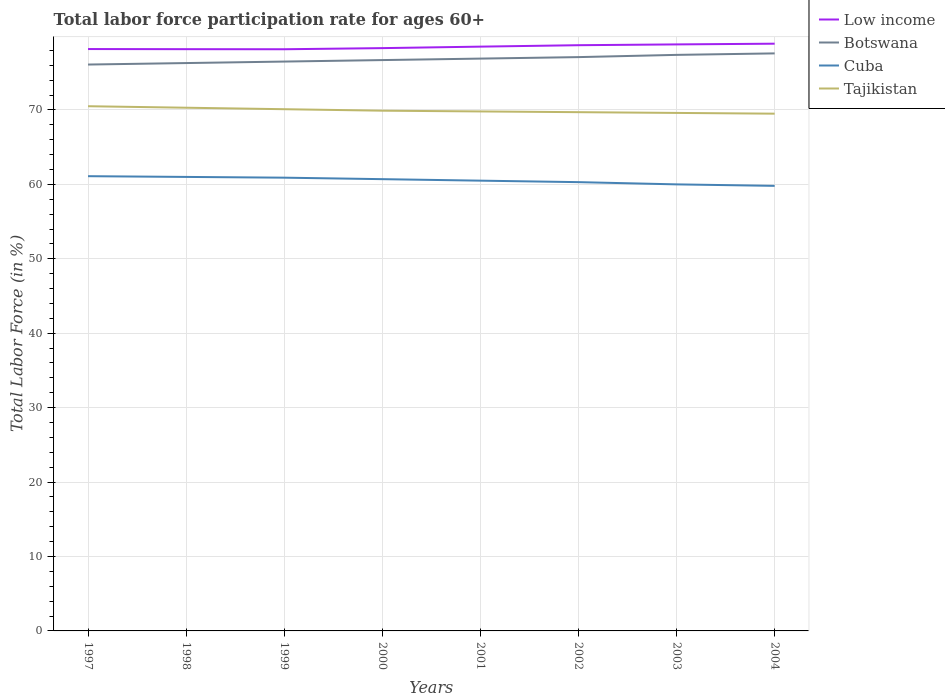Is the number of lines equal to the number of legend labels?
Keep it short and to the point. Yes. Across all years, what is the maximum labor force participation rate in Tajikistan?
Provide a short and direct response. 69.5. What is the total labor force participation rate in Low income in the graph?
Offer a very short reply. 0.02. What is the difference between the highest and the lowest labor force participation rate in Tajikistan?
Give a very brief answer. 3. How many lines are there?
Your answer should be very brief. 4. How many years are there in the graph?
Make the answer very short. 8. Are the values on the major ticks of Y-axis written in scientific E-notation?
Your response must be concise. No. Does the graph contain grids?
Keep it short and to the point. Yes. Where does the legend appear in the graph?
Your answer should be compact. Top right. How many legend labels are there?
Your answer should be very brief. 4. What is the title of the graph?
Your answer should be compact. Total labor force participation rate for ages 60+. What is the label or title of the X-axis?
Your answer should be compact. Years. What is the label or title of the Y-axis?
Offer a very short reply. Total Labor Force (in %). What is the Total Labor Force (in %) of Low income in 1997?
Offer a very short reply. 78.18. What is the Total Labor Force (in %) of Botswana in 1997?
Offer a very short reply. 76.1. What is the Total Labor Force (in %) in Cuba in 1997?
Offer a terse response. 61.1. What is the Total Labor Force (in %) of Tajikistan in 1997?
Provide a succinct answer. 70.5. What is the Total Labor Force (in %) in Low income in 1998?
Offer a terse response. 78.16. What is the Total Labor Force (in %) in Botswana in 1998?
Provide a short and direct response. 76.3. What is the Total Labor Force (in %) in Cuba in 1998?
Ensure brevity in your answer.  61. What is the Total Labor Force (in %) in Tajikistan in 1998?
Make the answer very short. 70.3. What is the Total Labor Force (in %) of Low income in 1999?
Offer a terse response. 78.16. What is the Total Labor Force (in %) of Botswana in 1999?
Provide a succinct answer. 76.5. What is the Total Labor Force (in %) of Cuba in 1999?
Ensure brevity in your answer.  60.9. What is the Total Labor Force (in %) in Tajikistan in 1999?
Your answer should be compact. 70.1. What is the Total Labor Force (in %) in Low income in 2000?
Provide a short and direct response. 78.31. What is the Total Labor Force (in %) of Botswana in 2000?
Provide a succinct answer. 76.7. What is the Total Labor Force (in %) of Cuba in 2000?
Your response must be concise. 60.7. What is the Total Labor Force (in %) in Tajikistan in 2000?
Make the answer very short. 69.9. What is the Total Labor Force (in %) of Low income in 2001?
Give a very brief answer. 78.51. What is the Total Labor Force (in %) of Botswana in 2001?
Provide a short and direct response. 76.9. What is the Total Labor Force (in %) of Cuba in 2001?
Keep it short and to the point. 60.5. What is the Total Labor Force (in %) of Tajikistan in 2001?
Make the answer very short. 69.8. What is the Total Labor Force (in %) of Low income in 2002?
Make the answer very short. 78.7. What is the Total Labor Force (in %) in Botswana in 2002?
Your answer should be compact. 77.1. What is the Total Labor Force (in %) of Cuba in 2002?
Provide a short and direct response. 60.3. What is the Total Labor Force (in %) of Tajikistan in 2002?
Provide a short and direct response. 69.7. What is the Total Labor Force (in %) of Low income in 2003?
Your response must be concise. 78.81. What is the Total Labor Force (in %) of Botswana in 2003?
Your answer should be compact. 77.4. What is the Total Labor Force (in %) in Tajikistan in 2003?
Keep it short and to the point. 69.6. What is the Total Labor Force (in %) in Low income in 2004?
Provide a short and direct response. 78.9. What is the Total Labor Force (in %) of Botswana in 2004?
Your response must be concise. 77.6. What is the Total Labor Force (in %) of Cuba in 2004?
Provide a short and direct response. 59.8. What is the Total Labor Force (in %) in Tajikistan in 2004?
Offer a terse response. 69.5. Across all years, what is the maximum Total Labor Force (in %) of Low income?
Make the answer very short. 78.9. Across all years, what is the maximum Total Labor Force (in %) in Botswana?
Your answer should be very brief. 77.6. Across all years, what is the maximum Total Labor Force (in %) of Cuba?
Your answer should be compact. 61.1. Across all years, what is the maximum Total Labor Force (in %) of Tajikistan?
Give a very brief answer. 70.5. Across all years, what is the minimum Total Labor Force (in %) of Low income?
Your answer should be very brief. 78.16. Across all years, what is the minimum Total Labor Force (in %) in Botswana?
Give a very brief answer. 76.1. Across all years, what is the minimum Total Labor Force (in %) of Cuba?
Keep it short and to the point. 59.8. Across all years, what is the minimum Total Labor Force (in %) of Tajikistan?
Your response must be concise. 69.5. What is the total Total Labor Force (in %) of Low income in the graph?
Keep it short and to the point. 627.72. What is the total Total Labor Force (in %) of Botswana in the graph?
Offer a terse response. 614.6. What is the total Total Labor Force (in %) in Cuba in the graph?
Ensure brevity in your answer.  484.3. What is the total Total Labor Force (in %) of Tajikistan in the graph?
Provide a short and direct response. 559.4. What is the difference between the Total Labor Force (in %) in Low income in 1997 and that in 1998?
Keep it short and to the point. 0.02. What is the difference between the Total Labor Force (in %) in Cuba in 1997 and that in 1998?
Your answer should be compact. 0.1. What is the difference between the Total Labor Force (in %) in Low income in 1997 and that in 1999?
Give a very brief answer. 0.03. What is the difference between the Total Labor Force (in %) in Botswana in 1997 and that in 1999?
Your response must be concise. -0.4. What is the difference between the Total Labor Force (in %) in Cuba in 1997 and that in 1999?
Keep it short and to the point. 0.2. What is the difference between the Total Labor Force (in %) in Low income in 1997 and that in 2000?
Keep it short and to the point. -0.12. What is the difference between the Total Labor Force (in %) of Botswana in 1997 and that in 2000?
Keep it short and to the point. -0.6. What is the difference between the Total Labor Force (in %) of Cuba in 1997 and that in 2000?
Give a very brief answer. 0.4. What is the difference between the Total Labor Force (in %) of Low income in 1997 and that in 2001?
Provide a succinct answer. -0.33. What is the difference between the Total Labor Force (in %) in Botswana in 1997 and that in 2001?
Your answer should be compact. -0.8. What is the difference between the Total Labor Force (in %) in Cuba in 1997 and that in 2001?
Your response must be concise. 0.6. What is the difference between the Total Labor Force (in %) of Low income in 1997 and that in 2002?
Ensure brevity in your answer.  -0.52. What is the difference between the Total Labor Force (in %) of Cuba in 1997 and that in 2002?
Provide a succinct answer. 0.8. What is the difference between the Total Labor Force (in %) in Low income in 1997 and that in 2003?
Give a very brief answer. -0.62. What is the difference between the Total Labor Force (in %) in Cuba in 1997 and that in 2003?
Give a very brief answer. 1.1. What is the difference between the Total Labor Force (in %) in Tajikistan in 1997 and that in 2003?
Provide a succinct answer. 0.9. What is the difference between the Total Labor Force (in %) in Low income in 1997 and that in 2004?
Give a very brief answer. -0.72. What is the difference between the Total Labor Force (in %) of Botswana in 1997 and that in 2004?
Your answer should be compact. -1.5. What is the difference between the Total Labor Force (in %) of Cuba in 1997 and that in 2004?
Make the answer very short. 1.3. What is the difference between the Total Labor Force (in %) in Low income in 1998 and that in 1999?
Ensure brevity in your answer.  0.01. What is the difference between the Total Labor Force (in %) in Botswana in 1998 and that in 1999?
Provide a short and direct response. -0.2. What is the difference between the Total Labor Force (in %) in Low income in 1998 and that in 2000?
Ensure brevity in your answer.  -0.14. What is the difference between the Total Labor Force (in %) of Botswana in 1998 and that in 2000?
Your answer should be compact. -0.4. What is the difference between the Total Labor Force (in %) in Tajikistan in 1998 and that in 2000?
Provide a succinct answer. 0.4. What is the difference between the Total Labor Force (in %) of Low income in 1998 and that in 2001?
Keep it short and to the point. -0.34. What is the difference between the Total Labor Force (in %) in Cuba in 1998 and that in 2001?
Your answer should be compact. 0.5. What is the difference between the Total Labor Force (in %) in Low income in 1998 and that in 2002?
Provide a succinct answer. -0.53. What is the difference between the Total Labor Force (in %) of Tajikistan in 1998 and that in 2002?
Make the answer very short. 0.6. What is the difference between the Total Labor Force (in %) of Low income in 1998 and that in 2003?
Your response must be concise. -0.64. What is the difference between the Total Labor Force (in %) of Botswana in 1998 and that in 2003?
Offer a terse response. -1.1. What is the difference between the Total Labor Force (in %) in Low income in 1998 and that in 2004?
Offer a very short reply. -0.74. What is the difference between the Total Labor Force (in %) in Botswana in 1998 and that in 2004?
Provide a short and direct response. -1.3. What is the difference between the Total Labor Force (in %) of Tajikistan in 1998 and that in 2004?
Offer a terse response. 0.8. What is the difference between the Total Labor Force (in %) in Low income in 1999 and that in 2000?
Provide a succinct answer. -0.15. What is the difference between the Total Labor Force (in %) of Cuba in 1999 and that in 2000?
Offer a terse response. 0.2. What is the difference between the Total Labor Force (in %) in Tajikistan in 1999 and that in 2000?
Keep it short and to the point. 0.2. What is the difference between the Total Labor Force (in %) in Low income in 1999 and that in 2001?
Your answer should be compact. -0.35. What is the difference between the Total Labor Force (in %) in Low income in 1999 and that in 2002?
Your response must be concise. -0.54. What is the difference between the Total Labor Force (in %) in Botswana in 1999 and that in 2002?
Your answer should be compact. -0.6. What is the difference between the Total Labor Force (in %) in Cuba in 1999 and that in 2002?
Keep it short and to the point. 0.6. What is the difference between the Total Labor Force (in %) in Tajikistan in 1999 and that in 2002?
Your answer should be compact. 0.4. What is the difference between the Total Labor Force (in %) of Low income in 1999 and that in 2003?
Your response must be concise. -0.65. What is the difference between the Total Labor Force (in %) of Botswana in 1999 and that in 2003?
Give a very brief answer. -0.9. What is the difference between the Total Labor Force (in %) in Cuba in 1999 and that in 2003?
Your answer should be very brief. 0.9. What is the difference between the Total Labor Force (in %) of Tajikistan in 1999 and that in 2003?
Offer a terse response. 0.5. What is the difference between the Total Labor Force (in %) in Low income in 1999 and that in 2004?
Provide a short and direct response. -0.75. What is the difference between the Total Labor Force (in %) in Botswana in 1999 and that in 2004?
Your answer should be compact. -1.1. What is the difference between the Total Labor Force (in %) of Low income in 2000 and that in 2001?
Provide a short and direct response. -0.2. What is the difference between the Total Labor Force (in %) of Botswana in 2000 and that in 2001?
Your response must be concise. -0.2. What is the difference between the Total Labor Force (in %) of Low income in 2000 and that in 2002?
Your answer should be very brief. -0.39. What is the difference between the Total Labor Force (in %) in Low income in 2000 and that in 2003?
Offer a very short reply. -0.5. What is the difference between the Total Labor Force (in %) in Botswana in 2000 and that in 2003?
Your answer should be compact. -0.7. What is the difference between the Total Labor Force (in %) of Cuba in 2000 and that in 2003?
Your response must be concise. 0.7. What is the difference between the Total Labor Force (in %) of Low income in 2000 and that in 2004?
Provide a short and direct response. -0.6. What is the difference between the Total Labor Force (in %) of Botswana in 2000 and that in 2004?
Your response must be concise. -0.9. What is the difference between the Total Labor Force (in %) of Cuba in 2000 and that in 2004?
Keep it short and to the point. 0.9. What is the difference between the Total Labor Force (in %) of Tajikistan in 2000 and that in 2004?
Keep it short and to the point. 0.4. What is the difference between the Total Labor Force (in %) of Low income in 2001 and that in 2002?
Your answer should be very brief. -0.19. What is the difference between the Total Labor Force (in %) in Botswana in 2001 and that in 2002?
Offer a terse response. -0.2. What is the difference between the Total Labor Force (in %) of Low income in 2001 and that in 2003?
Give a very brief answer. -0.3. What is the difference between the Total Labor Force (in %) in Cuba in 2001 and that in 2003?
Provide a succinct answer. 0.5. What is the difference between the Total Labor Force (in %) in Low income in 2001 and that in 2004?
Offer a terse response. -0.4. What is the difference between the Total Labor Force (in %) of Low income in 2002 and that in 2003?
Give a very brief answer. -0.11. What is the difference between the Total Labor Force (in %) of Botswana in 2002 and that in 2003?
Keep it short and to the point. -0.3. What is the difference between the Total Labor Force (in %) of Tajikistan in 2002 and that in 2003?
Make the answer very short. 0.1. What is the difference between the Total Labor Force (in %) in Low income in 2002 and that in 2004?
Offer a terse response. -0.2. What is the difference between the Total Labor Force (in %) in Low income in 2003 and that in 2004?
Give a very brief answer. -0.1. What is the difference between the Total Labor Force (in %) in Tajikistan in 2003 and that in 2004?
Offer a very short reply. 0.1. What is the difference between the Total Labor Force (in %) of Low income in 1997 and the Total Labor Force (in %) of Botswana in 1998?
Provide a short and direct response. 1.88. What is the difference between the Total Labor Force (in %) in Low income in 1997 and the Total Labor Force (in %) in Cuba in 1998?
Provide a short and direct response. 17.18. What is the difference between the Total Labor Force (in %) of Low income in 1997 and the Total Labor Force (in %) of Tajikistan in 1998?
Your answer should be very brief. 7.88. What is the difference between the Total Labor Force (in %) of Botswana in 1997 and the Total Labor Force (in %) of Cuba in 1998?
Your answer should be compact. 15.1. What is the difference between the Total Labor Force (in %) of Cuba in 1997 and the Total Labor Force (in %) of Tajikistan in 1998?
Make the answer very short. -9.2. What is the difference between the Total Labor Force (in %) of Low income in 1997 and the Total Labor Force (in %) of Botswana in 1999?
Make the answer very short. 1.68. What is the difference between the Total Labor Force (in %) in Low income in 1997 and the Total Labor Force (in %) in Cuba in 1999?
Provide a short and direct response. 17.28. What is the difference between the Total Labor Force (in %) of Low income in 1997 and the Total Labor Force (in %) of Tajikistan in 1999?
Your response must be concise. 8.08. What is the difference between the Total Labor Force (in %) of Botswana in 1997 and the Total Labor Force (in %) of Tajikistan in 1999?
Provide a succinct answer. 6. What is the difference between the Total Labor Force (in %) in Cuba in 1997 and the Total Labor Force (in %) in Tajikistan in 1999?
Offer a very short reply. -9. What is the difference between the Total Labor Force (in %) of Low income in 1997 and the Total Labor Force (in %) of Botswana in 2000?
Offer a very short reply. 1.48. What is the difference between the Total Labor Force (in %) in Low income in 1997 and the Total Labor Force (in %) in Cuba in 2000?
Ensure brevity in your answer.  17.48. What is the difference between the Total Labor Force (in %) in Low income in 1997 and the Total Labor Force (in %) in Tajikistan in 2000?
Your answer should be compact. 8.28. What is the difference between the Total Labor Force (in %) of Cuba in 1997 and the Total Labor Force (in %) of Tajikistan in 2000?
Make the answer very short. -8.8. What is the difference between the Total Labor Force (in %) in Low income in 1997 and the Total Labor Force (in %) in Botswana in 2001?
Make the answer very short. 1.28. What is the difference between the Total Labor Force (in %) in Low income in 1997 and the Total Labor Force (in %) in Cuba in 2001?
Your response must be concise. 17.68. What is the difference between the Total Labor Force (in %) in Low income in 1997 and the Total Labor Force (in %) in Tajikistan in 2001?
Keep it short and to the point. 8.38. What is the difference between the Total Labor Force (in %) of Botswana in 1997 and the Total Labor Force (in %) of Tajikistan in 2001?
Offer a terse response. 6.3. What is the difference between the Total Labor Force (in %) in Cuba in 1997 and the Total Labor Force (in %) in Tajikistan in 2001?
Your answer should be compact. -8.7. What is the difference between the Total Labor Force (in %) of Low income in 1997 and the Total Labor Force (in %) of Botswana in 2002?
Ensure brevity in your answer.  1.08. What is the difference between the Total Labor Force (in %) in Low income in 1997 and the Total Labor Force (in %) in Cuba in 2002?
Your answer should be compact. 17.88. What is the difference between the Total Labor Force (in %) of Low income in 1997 and the Total Labor Force (in %) of Tajikistan in 2002?
Provide a succinct answer. 8.48. What is the difference between the Total Labor Force (in %) in Botswana in 1997 and the Total Labor Force (in %) in Cuba in 2002?
Offer a terse response. 15.8. What is the difference between the Total Labor Force (in %) in Botswana in 1997 and the Total Labor Force (in %) in Tajikistan in 2002?
Give a very brief answer. 6.4. What is the difference between the Total Labor Force (in %) in Cuba in 1997 and the Total Labor Force (in %) in Tajikistan in 2002?
Make the answer very short. -8.6. What is the difference between the Total Labor Force (in %) of Low income in 1997 and the Total Labor Force (in %) of Botswana in 2003?
Provide a short and direct response. 0.78. What is the difference between the Total Labor Force (in %) of Low income in 1997 and the Total Labor Force (in %) of Cuba in 2003?
Offer a very short reply. 18.18. What is the difference between the Total Labor Force (in %) of Low income in 1997 and the Total Labor Force (in %) of Tajikistan in 2003?
Keep it short and to the point. 8.58. What is the difference between the Total Labor Force (in %) in Botswana in 1997 and the Total Labor Force (in %) in Cuba in 2003?
Provide a short and direct response. 16.1. What is the difference between the Total Labor Force (in %) of Botswana in 1997 and the Total Labor Force (in %) of Tajikistan in 2003?
Keep it short and to the point. 6.5. What is the difference between the Total Labor Force (in %) of Low income in 1997 and the Total Labor Force (in %) of Botswana in 2004?
Give a very brief answer. 0.58. What is the difference between the Total Labor Force (in %) in Low income in 1997 and the Total Labor Force (in %) in Cuba in 2004?
Your response must be concise. 18.38. What is the difference between the Total Labor Force (in %) of Low income in 1997 and the Total Labor Force (in %) of Tajikistan in 2004?
Your answer should be very brief. 8.68. What is the difference between the Total Labor Force (in %) of Botswana in 1997 and the Total Labor Force (in %) of Cuba in 2004?
Offer a terse response. 16.3. What is the difference between the Total Labor Force (in %) of Botswana in 1997 and the Total Labor Force (in %) of Tajikistan in 2004?
Provide a short and direct response. 6.6. What is the difference between the Total Labor Force (in %) of Cuba in 1997 and the Total Labor Force (in %) of Tajikistan in 2004?
Your answer should be compact. -8.4. What is the difference between the Total Labor Force (in %) in Low income in 1998 and the Total Labor Force (in %) in Botswana in 1999?
Offer a very short reply. 1.66. What is the difference between the Total Labor Force (in %) of Low income in 1998 and the Total Labor Force (in %) of Cuba in 1999?
Provide a succinct answer. 17.26. What is the difference between the Total Labor Force (in %) of Low income in 1998 and the Total Labor Force (in %) of Tajikistan in 1999?
Your answer should be very brief. 8.06. What is the difference between the Total Labor Force (in %) in Cuba in 1998 and the Total Labor Force (in %) in Tajikistan in 1999?
Give a very brief answer. -9.1. What is the difference between the Total Labor Force (in %) in Low income in 1998 and the Total Labor Force (in %) in Botswana in 2000?
Offer a very short reply. 1.46. What is the difference between the Total Labor Force (in %) of Low income in 1998 and the Total Labor Force (in %) of Cuba in 2000?
Offer a terse response. 17.46. What is the difference between the Total Labor Force (in %) in Low income in 1998 and the Total Labor Force (in %) in Tajikistan in 2000?
Give a very brief answer. 8.26. What is the difference between the Total Labor Force (in %) of Botswana in 1998 and the Total Labor Force (in %) of Cuba in 2000?
Keep it short and to the point. 15.6. What is the difference between the Total Labor Force (in %) of Low income in 1998 and the Total Labor Force (in %) of Botswana in 2001?
Your answer should be very brief. 1.26. What is the difference between the Total Labor Force (in %) in Low income in 1998 and the Total Labor Force (in %) in Cuba in 2001?
Your response must be concise. 17.66. What is the difference between the Total Labor Force (in %) in Low income in 1998 and the Total Labor Force (in %) in Tajikistan in 2001?
Provide a succinct answer. 8.36. What is the difference between the Total Labor Force (in %) of Low income in 1998 and the Total Labor Force (in %) of Botswana in 2002?
Provide a succinct answer. 1.06. What is the difference between the Total Labor Force (in %) of Low income in 1998 and the Total Labor Force (in %) of Cuba in 2002?
Make the answer very short. 17.86. What is the difference between the Total Labor Force (in %) in Low income in 1998 and the Total Labor Force (in %) in Tajikistan in 2002?
Ensure brevity in your answer.  8.46. What is the difference between the Total Labor Force (in %) of Low income in 1998 and the Total Labor Force (in %) of Botswana in 2003?
Your answer should be very brief. 0.76. What is the difference between the Total Labor Force (in %) of Low income in 1998 and the Total Labor Force (in %) of Cuba in 2003?
Give a very brief answer. 18.16. What is the difference between the Total Labor Force (in %) of Low income in 1998 and the Total Labor Force (in %) of Tajikistan in 2003?
Offer a very short reply. 8.56. What is the difference between the Total Labor Force (in %) in Botswana in 1998 and the Total Labor Force (in %) in Cuba in 2003?
Keep it short and to the point. 16.3. What is the difference between the Total Labor Force (in %) in Low income in 1998 and the Total Labor Force (in %) in Botswana in 2004?
Make the answer very short. 0.56. What is the difference between the Total Labor Force (in %) in Low income in 1998 and the Total Labor Force (in %) in Cuba in 2004?
Offer a terse response. 18.36. What is the difference between the Total Labor Force (in %) in Low income in 1998 and the Total Labor Force (in %) in Tajikistan in 2004?
Offer a very short reply. 8.66. What is the difference between the Total Labor Force (in %) of Cuba in 1998 and the Total Labor Force (in %) of Tajikistan in 2004?
Offer a terse response. -8.5. What is the difference between the Total Labor Force (in %) of Low income in 1999 and the Total Labor Force (in %) of Botswana in 2000?
Your answer should be compact. 1.46. What is the difference between the Total Labor Force (in %) in Low income in 1999 and the Total Labor Force (in %) in Cuba in 2000?
Your answer should be very brief. 17.46. What is the difference between the Total Labor Force (in %) of Low income in 1999 and the Total Labor Force (in %) of Tajikistan in 2000?
Your response must be concise. 8.26. What is the difference between the Total Labor Force (in %) in Botswana in 1999 and the Total Labor Force (in %) in Cuba in 2000?
Your response must be concise. 15.8. What is the difference between the Total Labor Force (in %) of Low income in 1999 and the Total Labor Force (in %) of Botswana in 2001?
Your answer should be very brief. 1.26. What is the difference between the Total Labor Force (in %) in Low income in 1999 and the Total Labor Force (in %) in Cuba in 2001?
Your response must be concise. 17.66. What is the difference between the Total Labor Force (in %) of Low income in 1999 and the Total Labor Force (in %) of Tajikistan in 2001?
Provide a short and direct response. 8.36. What is the difference between the Total Labor Force (in %) of Low income in 1999 and the Total Labor Force (in %) of Botswana in 2002?
Make the answer very short. 1.06. What is the difference between the Total Labor Force (in %) in Low income in 1999 and the Total Labor Force (in %) in Cuba in 2002?
Your answer should be compact. 17.86. What is the difference between the Total Labor Force (in %) of Low income in 1999 and the Total Labor Force (in %) of Tajikistan in 2002?
Your answer should be compact. 8.46. What is the difference between the Total Labor Force (in %) of Botswana in 1999 and the Total Labor Force (in %) of Cuba in 2002?
Your answer should be very brief. 16.2. What is the difference between the Total Labor Force (in %) of Cuba in 1999 and the Total Labor Force (in %) of Tajikistan in 2002?
Offer a very short reply. -8.8. What is the difference between the Total Labor Force (in %) in Low income in 1999 and the Total Labor Force (in %) in Botswana in 2003?
Your response must be concise. 0.76. What is the difference between the Total Labor Force (in %) of Low income in 1999 and the Total Labor Force (in %) of Cuba in 2003?
Your answer should be compact. 18.16. What is the difference between the Total Labor Force (in %) of Low income in 1999 and the Total Labor Force (in %) of Tajikistan in 2003?
Make the answer very short. 8.56. What is the difference between the Total Labor Force (in %) of Botswana in 1999 and the Total Labor Force (in %) of Tajikistan in 2003?
Offer a terse response. 6.9. What is the difference between the Total Labor Force (in %) of Low income in 1999 and the Total Labor Force (in %) of Botswana in 2004?
Ensure brevity in your answer.  0.56. What is the difference between the Total Labor Force (in %) of Low income in 1999 and the Total Labor Force (in %) of Cuba in 2004?
Provide a short and direct response. 18.36. What is the difference between the Total Labor Force (in %) of Low income in 1999 and the Total Labor Force (in %) of Tajikistan in 2004?
Ensure brevity in your answer.  8.66. What is the difference between the Total Labor Force (in %) of Low income in 2000 and the Total Labor Force (in %) of Botswana in 2001?
Your response must be concise. 1.41. What is the difference between the Total Labor Force (in %) of Low income in 2000 and the Total Labor Force (in %) of Cuba in 2001?
Make the answer very short. 17.81. What is the difference between the Total Labor Force (in %) in Low income in 2000 and the Total Labor Force (in %) in Tajikistan in 2001?
Ensure brevity in your answer.  8.51. What is the difference between the Total Labor Force (in %) of Botswana in 2000 and the Total Labor Force (in %) of Tajikistan in 2001?
Make the answer very short. 6.9. What is the difference between the Total Labor Force (in %) of Cuba in 2000 and the Total Labor Force (in %) of Tajikistan in 2001?
Provide a short and direct response. -9.1. What is the difference between the Total Labor Force (in %) in Low income in 2000 and the Total Labor Force (in %) in Botswana in 2002?
Offer a very short reply. 1.21. What is the difference between the Total Labor Force (in %) in Low income in 2000 and the Total Labor Force (in %) in Cuba in 2002?
Make the answer very short. 18.01. What is the difference between the Total Labor Force (in %) of Low income in 2000 and the Total Labor Force (in %) of Tajikistan in 2002?
Make the answer very short. 8.61. What is the difference between the Total Labor Force (in %) in Botswana in 2000 and the Total Labor Force (in %) in Tajikistan in 2002?
Your answer should be very brief. 7. What is the difference between the Total Labor Force (in %) in Cuba in 2000 and the Total Labor Force (in %) in Tajikistan in 2002?
Offer a terse response. -9. What is the difference between the Total Labor Force (in %) of Low income in 2000 and the Total Labor Force (in %) of Botswana in 2003?
Your answer should be compact. 0.91. What is the difference between the Total Labor Force (in %) in Low income in 2000 and the Total Labor Force (in %) in Cuba in 2003?
Offer a very short reply. 18.31. What is the difference between the Total Labor Force (in %) in Low income in 2000 and the Total Labor Force (in %) in Tajikistan in 2003?
Your answer should be compact. 8.71. What is the difference between the Total Labor Force (in %) of Botswana in 2000 and the Total Labor Force (in %) of Cuba in 2003?
Make the answer very short. 16.7. What is the difference between the Total Labor Force (in %) in Botswana in 2000 and the Total Labor Force (in %) in Tajikistan in 2003?
Provide a succinct answer. 7.1. What is the difference between the Total Labor Force (in %) of Low income in 2000 and the Total Labor Force (in %) of Botswana in 2004?
Offer a very short reply. 0.71. What is the difference between the Total Labor Force (in %) of Low income in 2000 and the Total Labor Force (in %) of Cuba in 2004?
Your answer should be compact. 18.51. What is the difference between the Total Labor Force (in %) of Low income in 2000 and the Total Labor Force (in %) of Tajikistan in 2004?
Ensure brevity in your answer.  8.81. What is the difference between the Total Labor Force (in %) of Botswana in 2000 and the Total Labor Force (in %) of Cuba in 2004?
Offer a terse response. 16.9. What is the difference between the Total Labor Force (in %) of Cuba in 2000 and the Total Labor Force (in %) of Tajikistan in 2004?
Your answer should be compact. -8.8. What is the difference between the Total Labor Force (in %) of Low income in 2001 and the Total Labor Force (in %) of Botswana in 2002?
Your response must be concise. 1.41. What is the difference between the Total Labor Force (in %) in Low income in 2001 and the Total Labor Force (in %) in Cuba in 2002?
Keep it short and to the point. 18.21. What is the difference between the Total Labor Force (in %) in Low income in 2001 and the Total Labor Force (in %) in Tajikistan in 2002?
Make the answer very short. 8.81. What is the difference between the Total Labor Force (in %) in Cuba in 2001 and the Total Labor Force (in %) in Tajikistan in 2002?
Keep it short and to the point. -9.2. What is the difference between the Total Labor Force (in %) in Low income in 2001 and the Total Labor Force (in %) in Botswana in 2003?
Offer a terse response. 1.11. What is the difference between the Total Labor Force (in %) in Low income in 2001 and the Total Labor Force (in %) in Cuba in 2003?
Offer a terse response. 18.51. What is the difference between the Total Labor Force (in %) in Low income in 2001 and the Total Labor Force (in %) in Tajikistan in 2003?
Provide a short and direct response. 8.91. What is the difference between the Total Labor Force (in %) in Botswana in 2001 and the Total Labor Force (in %) in Cuba in 2003?
Your answer should be very brief. 16.9. What is the difference between the Total Labor Force (in %) in Low income in 2001 and the Total Labor Force (in %) in Botswana in 2004?
Offer a terse response. 0.91. What is the difference between the Total Labor Force (in %) in Low income in 2001 and the Total Labor Force (in %) in Cuba in 2004?
Ensure brevity in your answer.  18.71. What is the difference between the Total Labor Force (in %) in Low income in 2001 and the Total Labor Force (in %) in Tajikistan in 2004?
Provide a short and direct response. 9.01. What is the difference between the Total Labor Force (in %) in Botswana in 2001 and the Total Labor Force (in %) in Cuba in 2004?
Ensure brevity in your answer.  17.1. What is the difference between the Total Labor Force (in %) in Botswana in 2001 and the Total Labor Force (in %) in Tajikistan in 2004?
Keep it short and to the point. 7.4. What is the difference between the Total Labor Force (in %) in Low income in 2002 and the Total Labor Force (in %) in Botswana in 2003?
Offer a very short reply. 1.3. What is the difference between the Total Labor Force (in %) in Low income in 2002 and the Total Labor Force (in %) in Cuba in 2003?
Offer a very short reply. 18.7. What is the difference between the Total Labor Force (in %) in Low income in 2002 and the Total Labor Force (in %) in Tajikistan in 2003?
Offer a terse response. 9.1. What is the difference between the Total Labor Force (in %) in Botswana in 2002 and the Total Labor Force (in %) in Cuba in 2003?
Offer a terse response. 17.1. What is the difference between the Total Labor Force (in %) of Cuba in 2002 and the Total Labor Force (in %) of Tajikistan in 2003?
Ensure brevity in your answer.  -9.3. What is the difference between the Total Labor Force (in %) of Low income in 2002 and the Total Labor Force (in %) of Botswana in 2004?
Provide a short and direct response. 1.1. What is the difference between the Total Labor Force (in %) of Low income in 2002 and the Total Labor Force (in %) of Cuba in 2004?
Your answer should be compact. 18.9. What is the difference between the Total Labor Force (in %) of Low income in 2002 and the Total Labor Force (in %) of Tajikistan in 2004?
Your response must be concise. 9.2. What is the difference between the Total Labor Force (in %) of Botswana in 2002 and the Total Labor Force (in %) of Cuba in 2004?
Keep it short and to the point. 17.3. What is the difference between the Total Labor Force (in %) of Botswana in 2002 and the Total Labor Force (in %) of Tajikistan in 2004?
Offer a terse response. 7.6. What is the difference between the Total Labor Force (in %) in Cuba in 2002 and the Total Labor Force (in %) in Tajikistan in 2004?
Keep it short and to the point. -9.2. What is the difference between the Total Labor Force (in %) in Low income in 2003 and the Total Labor Force (in %) in Botswana in 2004?
Your answer should be very brief. 1.21. What is the difference between the Total Labor Force (in %) in Low income in 2003 and the Total Labor Force (in %) in Cuba in 2004?
Your answer should be very brief. 19.01. What is the difference between the Total Labor Force (in %) of Low income in 2003 and the Total Labor Force (in %) of Tajikistan in 2004?
Offer a terse response. 9.31. What is the difference between the Total Labor Force (in %) of Cuba in 2003 and the Total Labor Force (in %) of Tajikistan in 2004?
Provide a succinct answer. -9.5. What is the average Total Labor Force (in %) in Low income per year?
Ensure brevity in your answer.  78.47. What is the average Total Labor Force (in %) of Botswana per year?
Offer a very short reply. 76.83. What is the average Total Labor Force (in %) of Cuba per year?
Give a very brief answer. 60.54. What is the average Total Labor Force (in %) in Tajikistan per year?
Your answer should be very brief. 69.92. In the year 1997, what is the difference between the Total Labor Force (in %) of Low income and Total Labor Force (in %) of Botswana?
Offer a very short reply. 2.08. In the year 1997, what is the difference between the Total Labor Force (in %) of Low income and Total Labor Force (in %) of Cuba?
Give a very brief answer. 17.08. In the year 1997, what is the difference between the Total Labor Force (in %) of Low income and Total Labor Force (in %) of Tajikistan?
Keep it short and to the point. 7.68. In the year 1997, what is the difference between the Total Labor Force (in %) of Botswana and Total Labor Force (in %) of Tajikistan?
Keep it short and to the point. 5.6. In the year 1998, what is the difference between the Total Labor Force (in %) in Low income and Total Labor Force (in %) in Botswana?
Your response must be concise. 1.86. In the year 1998, what is the difference between the Total Labor Force (in %) of Low income and Total Labor Force (in %) of Cuba?
Keep it short and to the point. 17.16. In the year 1998, what is the difference between the Total Labor Force (in %) in Low income and Total Labor Force (in %) in Tajikistan?
Your answer should be very brief. 7.86. In the year 1998, what is the difference between the Total Labor Force (in %) in Botswana and Total Labor Force (in %) in Cuba?
Offer a very short reply. 15.3. In the year 1998, what is the difference between the Total Labor Force (in %) of Botswana and Total Labor Force (in %) of Tajikistan?
Make the answer very short. 6. In the year 1998, what is the difference between the Total Labor Force (in %) of Cuba and Total Labor Force (in %) of Tajikistan?
Your answer should be very brief. -9.3. In the year 1999, what is the difference between the Total Labor Force (in %) of Low income and Total Labor Force (in %) of Botswana?
Make the answer very short. 1.66. In the year 1999, what is the difference between the Total Labor Force (in %) of Low income and Total Labor Force (in %) of Cuba?
Offer a terse response. 17.26. In the year 1999, what is the difference between the Total Labor Force (in %) of Low income and Total Labor Force (in %) of Tajikistan?
Offer a very short reply. 8.06. In the year 1999, what is the difference between the Total Labor Force (in %) of Cuba and Total Labor Force (in %) of Tajikistan?
Provide a short and direct response. -9.2. In the year 2000, what is the difference between the Total Labor Force (in %) in Low income and Total Labor Force (in %) in Botswana?
Keep it short and to the point. 1.61. In the year 2000, what is the difference between the Total Labor Force (in %) of Low income and Total Labor Force (in %) of Cuba?
Provide a short and direct response. 17.61. In the year 2000, what is the difference between the Total Labor Force (in %) in Low income and Total Labor Force (in %) in Tajikistan?
Offer a terse response. 8.41. In the year 2000, what is the difference between the Total Labor Force (in %) of Botswana and Total Labor Force (in %) of Tajikistan?
Offer a very short reply. 6.8. In the year 2000, what is the difference between the Total Labor Force (in %) of Cuba and Total Labor Force (in %) of Tajikistan?
Offer a terse response. -9.2. In the year 2001, what is the difference between the Total Labor Force (in %) of Low income and Total Labor Force (in %) of Botswana?
Your answer should be very brief. 1.61. In the year 2001, what is the difference between the Total Labor Force (in %) in Low income and Total Labor Force (in %) in Cuba?
Give a very brief answer. 18.01. In the year 2001, what is the difference between the Total Labor Force (in %) in Low income and Total Labor Force (in %) in Tajikistan?
Ensure brevity in your answer.  8.71. In the year 2001, what is the difference between the Total Labor Force (in %) in Botswana and Total Labor Force (in %) in Cuba?
Provide a short and direct response. 16.4. In the year 2002, what is the difference between the Total Labor Force (in %) in Low income and Total Labor Force (in %) in Botswana?
Make the answer very short. 1.6. In the year 2002, what is the difference between the Total Labor Force (in %) of Low income and Total Labor Force (in %) of Cuba?
Offer a terse response. 18.4. In the year 2002, what is the difference between the Total Labor Force (in %) in Low income and Total Labor Force (in %) in Tajikistan?
Offer a very short reply. 9. In the year 2002, what is the difference between the Total Labor Force (in %) of Botswana and Total Labor Force (in %) of Tajikistan?
Your response must be concise. 7.4. In the year 2003, what is the difference between the Total Labor Force (in %) of Low income and Total Labor Force (in %) of Botswana?
Provide a short and direct response. 1.41. In the year 2003, what is the difference between the Total Labor Force (in %) in Low income and Total Labor Force (in %) in Cuba?
Offer a very short reply. 18.81. In the year 2003, what is the difference between the Total Labor Force (in %) of Low income and Total Labor Force (in %) of Tajikistan?
Make the answer very short. 9.21. In the year 2003, what is the difference between the Total Labor Force (in %) of Botswana and Total Labor Force (in %) of Cuba?
Offer a terse response. 17.4. In the year 2003, what is the difference between the Total Labor Force (in %) of Botswana and Total Labor Force (in %) of Tajikistan?
Your response must be concise. 7.8. In the year 2004, what is the difference between the Total Labor Force (in %) of Low income and Total Labor Force (in %) of Botswana?
Your answer should be compact. 1.3. In the year 2004, what is the difference between the Total Labor Force (in %) in Low income and Total Labor Force (in %) in Cuba?
Your response must be concise. 19.1. In the year 2004, what is the difference between the Total Labor Force (in %) of Low income and Total Labor Force (in %) of Tajikistan?
Your answer should be very brief. 9.4. In the year 2004, what is the difference between the Total Labor Force (in %) in Botswana and Total Labor Force (in %) in Tajikistan?
Give a very brief answer. 8.1. In the year 2004, what is the difference between the Total Labor Force (in %) in Cuba and Total Labor Force (in %) in Tajikistan?
Make the answer very short. -9.7. What is the ratio of the Total Labor Force (in %) of Cuba in 1997 to that in 1999?
Ensure brevity in your answer.  1. What is the ratio of the Total Labor Force (in %) of Tajikistan in 1997 to that in 1999?
Offer a very short reply. 1.01. What is the ratio of the Total Labor Force (in %) in Low income in 1997 to that in 2000?
Your answer should be compact. 1. What is the ratio of the Total Labor Force (in %) of Cuba in 1997 to that in 2000?
Give a very brief answer. 1.01. What is the ratio of the Total Labor Force (in %) of Tajikistan in 1997 to that in 2000?
Provide a short and direct response. 1.01. What is the ratio of the Total Labor Force (in %) in Cuba in 1997 to that in 2001?
Make the answer very short. 1.01. What is the ratio of the Total Labor Force (in %) of Tajikistan in 1997 to that in 2001?
Give a very brief answer. 1.01. What is the ratio of the Total Labor Force (in %) of Cuba in 1997 to that in 2002?
Provide a short and direct response. 1.01. What is the ratio of the Total Labor Force (in %) of Tajikistan in 1997 to that in 2002?
Provide a succinct answer. 1.01. What is the ratio of the Total Labor Force (in %) of Low income in 1997 to that in 2003?
Your response must be concise. 0.99. What is the ratio of the Total Labor Force (in %) of Botswana in 1997 to that in 2003?
Offer a terse response. 0.98. What is the ratio of the Total Labor Force (in %) in Cuba in 1997 to that in 2003?
Give a very brief answer. 1.02. What is the ratio of the Total Labor Force (in %) in Tajikistan in 1997 to that in 2003?
Keep it short and to the point. 1.01. What is the ratio of the Total Labor Force (in %) of Low income in 1997 to that in 2004?
Offer a terse response. 0.99. What is the ratio of the Total Labor Force (in %) in Botswana in 1997 to that in 2004?
Your answer should be compact. 0.98. What is the ratio of the Total Labor Force (in %) of Cuba in 1997 to that in 2004?
Make the answer very short. 1.02. What is the ratio of the Total Labor Force (in %) of Tajikistan in 1997 to that in 2004?
Your answer should be very brief. 1.01. What is the ratio of the Total Labor Force (in %) in Botswana in 1998 to that in 1999?
Keep it short and to the point. 1. What is the ratio of the Total Labor Force (in %) in Tajikistan in 1998 to that in 1999?
Offer a terse response. 1. What is the ratio of the Total Labor Force (in %) in Botswana in 1998 to that in 2000?
Offer a terse response. 0.99. What is the ratio of the Total Labor Force (in %) in Cuba in 1998 to that in 2000?
Make the answer very short. 1. What is the ratio of the Total Labor Force (in %) of Low income in 1998 to that in 2001?
Provide a succinct answer. 1. What is the ratio of the Total Labor Force (in %) in Cuba in 1998 to that in 2001?
Ensure brevity in your answer.  1.01. What is the ratio of the Total Labor Force (in %) in Tajikistan in 1998 to that in 2001?
Your response must be concise. 1.01. What is the ratio of the Total Labor Force (in %) in Botswana in 1998 to that in 2002?
Keep it short and to the point. 0.99. What is the ratio of the Total Labor Force (in %) in Cuba in 1998 to that in 2002?
Provide a short and direct response. 1.01. What is the ratio of the Total Labor Force (in %) of Tajikistan in 1998 to that in 2002?
Ensure brevity in your answer.  1.01. What is the ratio of the Total Labor Force (in %) in Botswana in 1998 to that in 2003?
Ensure brevity in your answer.  0.99. What is the ratio of the Total Labor Force (in %) in Cuba in 1998 to that in 2003?
Provide a short and direct response. 1.02. What is the ratio of the Total Labor Force (in %) in Low income in 1998 to that in 2004?
Offer a very short reply. 0.99. What is the ratio of the Total Labor Force (in %) of Botswana in 1998 to that in 2004?
Your response must be concise. 0.98. What is the ratio of the Total Labor Force (in %) in Cuba in 1998 to that in 2004?
Your answer should be compact. 1.02. What is the ratio of the Total Labor Force (in %) in Tajikistan in 1998 to that in 2004?
Keep it short and to the point. 1.01. What is the ratio of the Total Labor Force (in %) of Tajikistan in 1999 to that in 2000?
Provide a succinct answer. 1. What is the ratio of the Total Labor Force (in %) in Cuba in 1999 to that in 2001?
Keep it short and to the point. 1.01. What is the ratio of the Total Labor Force (in %) of Tajikistan in 1999 to that in 2001?
Keep it short and to the point. 1. What is the ratio of the Total Labor Force (in %) of Cuba in 1999 to that in 2002?
Ensure brevity in your answer.  1.01. What is the ratio of the Total Labor Force (in %) in Tajikistan in 1999 to that in 2002?
Provide a short and direct response. 1.01. What is the ratio of the Total Labor Force (in %) in Low income in 1999 to that in 2003?
Your answer should be compact. 0.99. What is the ratio of the Total Labor Force (in %) of Botswana in 1999 to that in 2003?
Your answer should be compact. 0.99. What is the ratio of the Total Labor Force (in %) of Tajikistan in 1999 to that in 2003?
Your response must be concise. 1.01. What is the ratio of the Total Labor Force (in %) in Low income in 1999 to that in 2004?
Keep it short and to the point. 0.99. What is the ratio of the Total Labor Force (in %) in Botswana in 1999 to that in 2004?
Ensure brevity in your answer.  0.99. What is the ratio of the Total Labor Force (in %) of Cuba in 1999 to that in 2004?
Your answer should be very brief. 1.02. What is the ratio of the Total Labor Force (in %) of Tajikistan in 1999 to that in 2004?
Keep it short and to the point. 1.01. What is the ratio of the Total Labor Force (in %) of Botswana in 2000 to that in 2001?
Ensure brevity in your answer.  1. What is the ratio of the Total Labor Force (in %) in Cuba in 2000 to that in 2001?
Your response must be concise. 1. What is the ratio of the Total Labor Force (in %) in Cuba in 2000 to that in 2002?
Your response must be concise. 1.01. What is the ratio of the Total Labor Force (in %) in Tajikistan in 2000 to that in 2002?
Your answer should be compact. 1. What is the ratio of the Total Labor Force (in %) in Low income in 2000 to that in 2003?
Keep it short and to the point. 0.99. What is the ratio of the Total Labor Force (in %) of Cuba in 2000 to that in 2003?
Offer a terse response. 1.01. What is the ratio of the Total Labor Force (in %) of Low income in 2000 to that in 2004?
Keep it short and to the point. 0.99. What is the ratio of the Total Labor Force (in %) of Botswana in 2000 to that in 2004?
Give a very brief answer. 0.99. What is the ratio of the Total Labor Force (in %) in Cuba in 2000 to that in 2004?
Keep it short and to the point. 1.02. What is the ratio of the Total Labor Force (in %) of Low income in 2001 to that in 2002?
Provide a short and direct response. 1. What is the ratio of the Total Labor Force (in %) in Botswana in 2001 to that in 2002?
Keep it short and to the point. 1. What is the ratio of the Total Labor Force (in %) of Cuba in 2001 to that in 2002?
Your answer should be very brief. 1. What is the ratio of the Total Labor Force (in %) in Cuba in 2001 to that in 2003?
Your response must be concise. 1.01. What is the ratio of the Total Labor Force (in %) in Botswana in 2001 to that in 2004?
Offer a terse response. 0.99. What is the ratio of the Total Labor Force (in %) of Cuba in 2001 to that in 2004?
Your answer should be compact. 1.01. What is the ratio of the Total Labor Force (in %) in Tajikistan in 2001 to that in 2004?
Provide a succinct answer. 1. What is the ratio of the Total Labor Force (in %) of Low income in 2002 to that in 2003?
Make the answer very short. 1. What is the ratio of the Total Labor Force (in %) in Botswana in 2002 to that in 2003?
Keep it short and to the point. 1. What is the ratio of the Total Labor Force (in %) in Tajikistan in 2002 to that in 2003?
Make the answer very short. 1. What is the ratio of the Total Labor Force (in %) in Botswana in 2002 to that in 2004?
Give a very brief answer. 0.99. What is the ratio of the Total Labor Force (in %) of Cuba in 2002 to that in 2004?
Provide a short and direct response. 1.01. What is the ratio of the Total Labor Force (in %) in Cuba in 2003 to that in 2004?
Provide a succinct answer. 1. What is the ratio of the Total Labor Force (in %) in Tajikistan in 2003 to that in 2004?
Provide a short and direct response. 1. What is the difference between the highest and the second highest Total Labor Force (in %) of Low income?
Offer a very short reply. 0.1. What is the difference between the highest and the second highest Total Labor Force (in %) of Cuba?
Offer a terse response. 0.1. What is the difference between the highest and the lowest Total Labor Force (in %) in Low income?
Provide a short and direct response. 0.75. What is the difference between the highest and the lowest Total Labor Force (in %) of Botswana?
Offer a very short reply. 1.5. What is the difference between the highest and the lowest Total Labor Force (in %) of Tajikistan?
Keep it short and to the point. 1. 